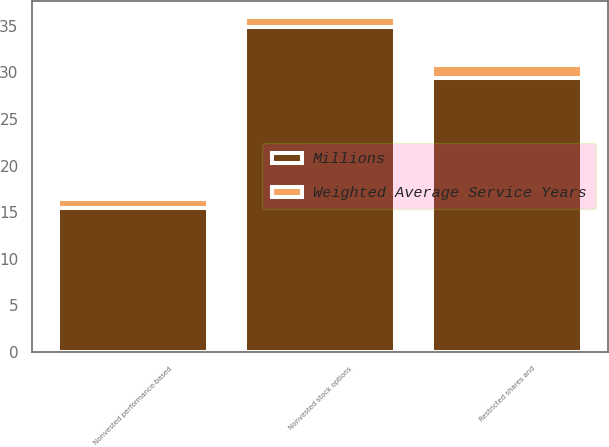Convert chart. <chart><loc_0><loc_0><loc_500><loc_500><stacked_bar_chart><ecel><fcel>Nonvested stock options<fcel>Restricted shares and<fcel>Nonvested performance-based<nl><fcel>Millions<fcel>34.9<fcel>29.4<fcel>15.5<nl><fcel>Weighted Average Service Years<fcel>1<fcel>1.4<fcel>0.9<nl></chart> 